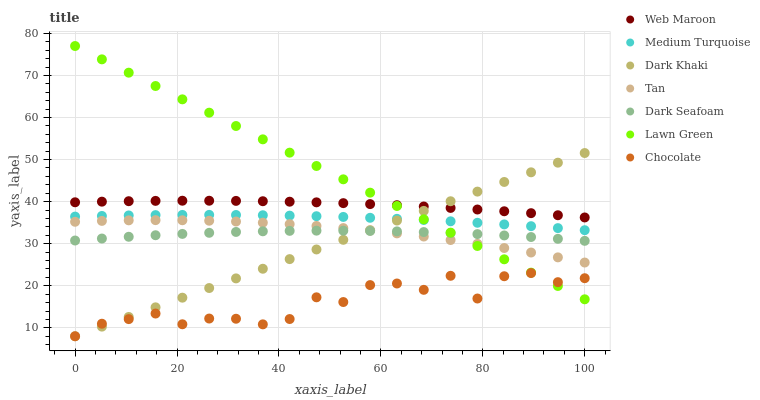Does Chocolate have the minimum area under the curve?
Answer yes or no. Yes. Does Lawn Green have the maximum area under the curve?
Answer yes or no. Yes. Does Web Maroon have the minimum area under the curve?
Answer yes or no. No. Does Web Maroon have the maximum area under the curve?
Answer yes or no. No. Is Dark Khaki the smoothest?
Answer yes or no. Yes. Is Chocolate the roughest?
Answer yes or no. Yes. Is Web Maroon the smoothest?
Answer yes or no. No. Is Web Maroon the roughest?
Answer yes or no. No. Does Chocolate have the lowest value?
Answer yes or no. Yes. Does Web Maroon have the lowest value?
Answer yes or no. No. Does Lawn Green have the highest value?
Answer yes or no. Yes. Does Web Maroon have the highest value?
Answer yes or no. No. Is Medium Turquoise less than Web Maroon?
Answer yes or no. Yes. Is Web Maroon greater than Medium Turquoise?
Answer yes or no. Yes. Does Dark Khaki intersect Lawn Green?
Answer yes or no. Yes. Is Dark Khaki less than Lawn Green?
Answer yes or no. No. Is Dark Khaki greater than Lawn Green?
Answer yes or no. No. Does Medium Turquoise intersect Web Maroon?
Answer yes or no. No. 